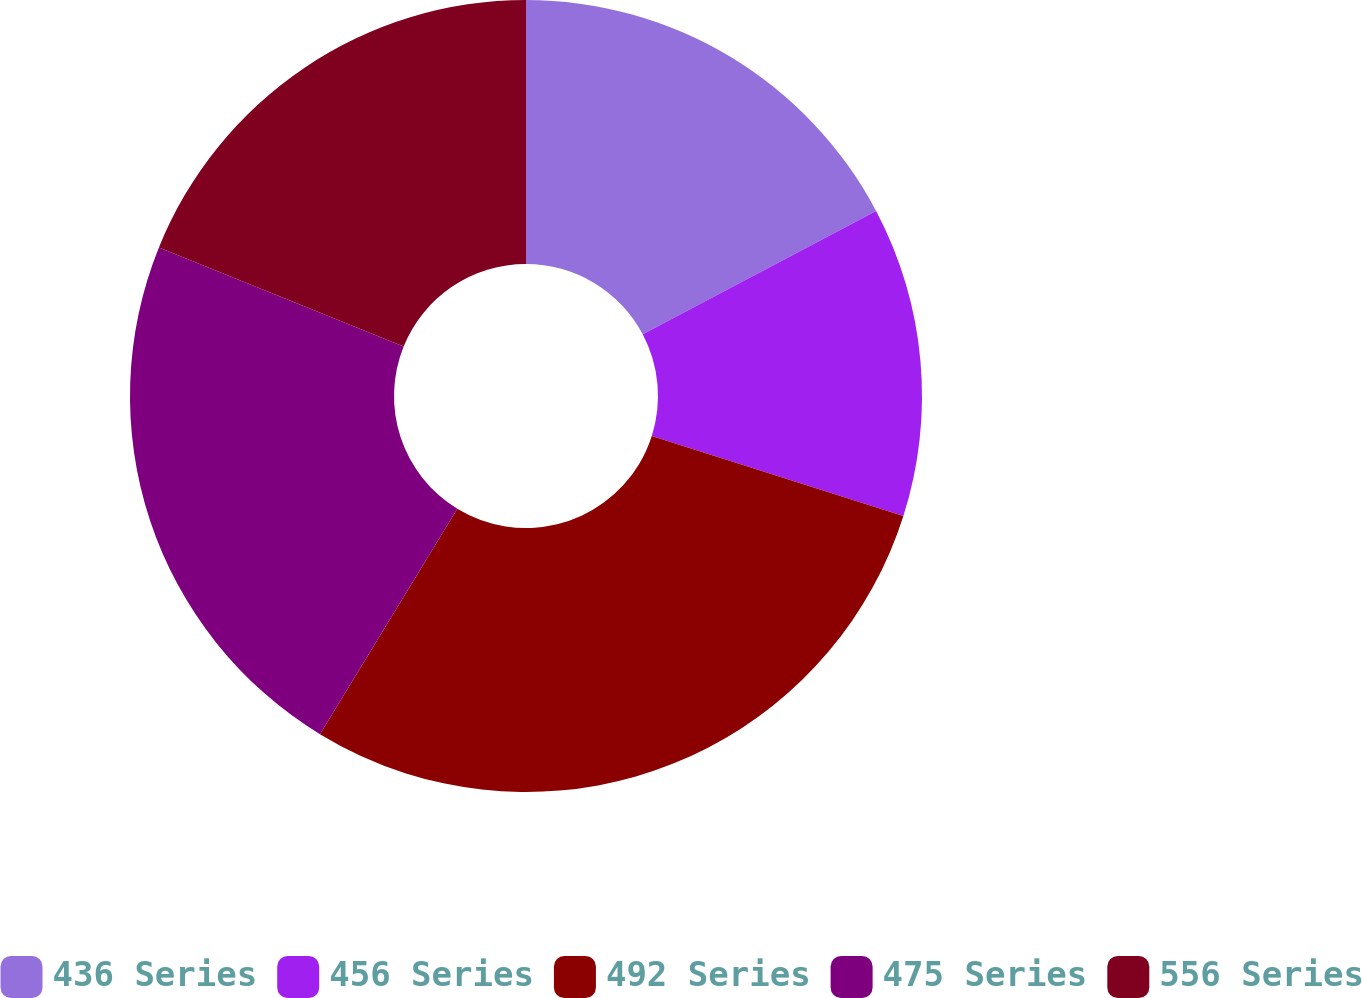Convert chart. <chart><loc_0><loc_0><loc_500><loc_500><pie_chart><fcel>436 Series<fcel>456 Series<fcel>492 Series<fcel>475 Series<fcel>556 Series<nl><fcel>17.26%<fcel>12.64%<fcel>28.81%<fcel>22.41%<fcel>18.88%<nl></chart> 